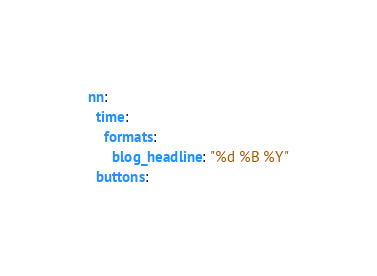Convert code to text. <code><loc_0><loc_0><loc_500><loc_500><_YAML_>nn:
  time:
    formats:
      blog_headline: "%d %B %Y"
  buttons:</code> 